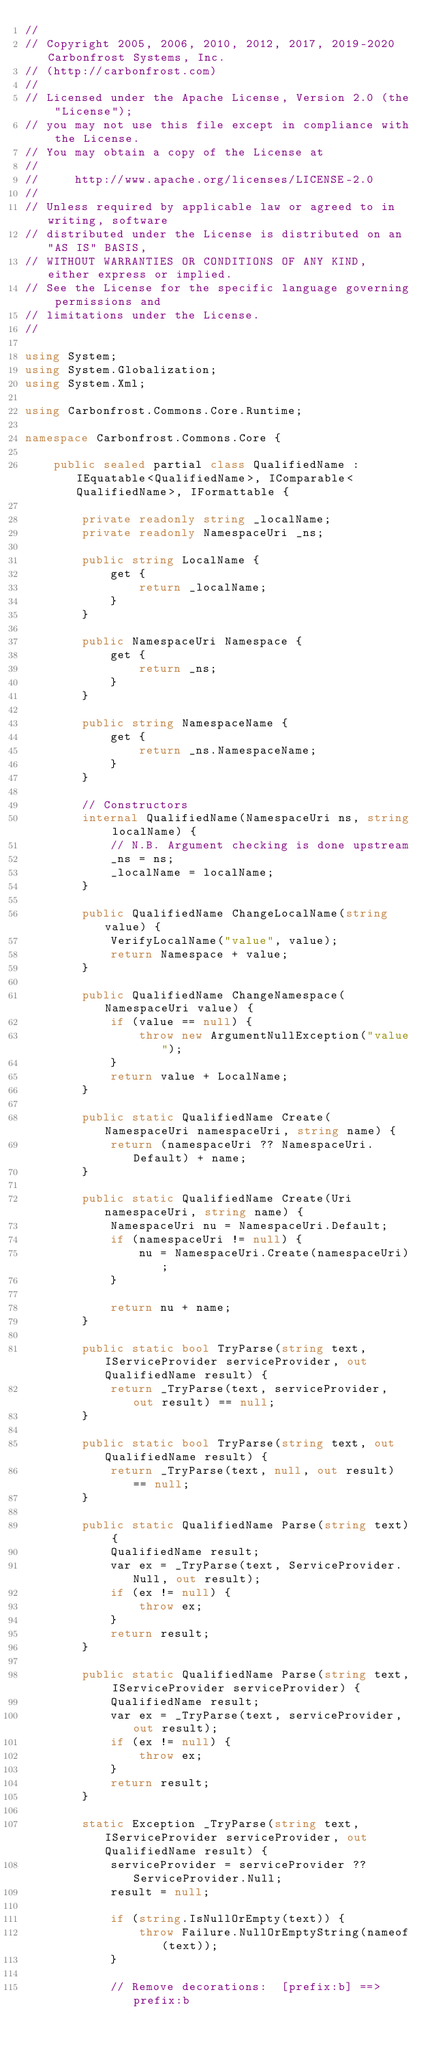Convert code to text. <code><loc_0><loc_0><loc_500><loc_500><_C#_>//
// Copyright 2005, 2006, 2010, 2012, 2017, 2019-2020 Carbonfrost Systems, Inc.
// (http://carbonfrost.com)
//
// Licensed under the Apache License, Version 2.0 (the "License");
// you may not use this file except in compliance with the License.
// You may obtain a copy of the License at
//
//     http://www.apache.org/licenses/LICENSE-2.0
//
// Unless required by applicable law or agreed to in writing, software
// distributed under the License is distributed on an "AS IS" BASIS,
// WITHOUT WARRANTIES OR CONDITIONS OF ANY KIND, either express or implied.
// See the License for the specific language governing permissions and
// limitations under the License.
//

using System;
using System.Globalization;
using System.Xml;

using Carbonfrost.Commons.Core.Runtime;

namespace Carbonfrost.Commons.Core {

    public sealed partial class QualifiedName : IEquatable<QualifiedName>, IComparable<QualifiedName>, IFormattable {

        private readonly string _localName;
        private readonly NamespaceUri _ns;

        public string LocalName {
            get {
                return _localName;
            }
        }

        public NamespaceUri Namespace {
            get {
                return _ns;
            }
        }

        public string NamespaceName {
            get {
                return _ns.NamespaceName;
            }
        }

        // Constructors
        internal QualifiedName(NamespaceUri ns, string localName) {
            // N.B. Argument checking is done upstream
            _ns = ns;
            _localName = localName;
        }

        public QualifiedName ChangeLocalName(string value) {
            VerifyLocalName("value", value);
            return Namespace + value;
        }

        public QualifiedName ChangeNamespace(NamespaceUri value) {
            if (value == null) {
                throw new ArgumentNullException("value");
            }
            return value + LocalName;
        }

        public static QualifiedName Create(NamespaceUri namespaceUri, string name) {
            return (namespaceUri ?? NamespaceUri.Default) + name;
        }

        public static QualifiedName Create(Uri namespaceUri, string name) {
            NamespaceUri nu = NamespaceUri.Default;
            if (namespaceUri != null) {
                nu = NamespaceUri.Create(namespaceUri);
            }

            return nu + name;
        }

        public static bool TryParse(string text, IServiceProvider serviceProvider, out QualifiedName result) {
            return _TryParse(text, serviceProvider, out result) == null;
        }

        public static bool TryParse(string text, out QualifiedName result) {
            return _TryParse(text, null, out result) == null;
        }

        public static QualifiedName Parse(string text) {
            QualifiedName result;
            var ex = _TryParse(text, ServiceProvider.Null, out result);
            if (ex != null) {
                throw ex;
            }
            return result;
        }

        public static QualifiedName Parse(string text, IServiceProvider serviceProvider) {
            QualifiedName result;
            var ex = _TryParse(text, serviceProvider, out result);
            if (ex != null) {
                throw ex;
            }
            return result;
        }

        static Exception _TryParse(string text, IServiceProvider serviceProvider, out QualifiedName result) {
            serviceProvider = serviceProvider ?? ServiceProvider.Null;
            result = null;

            if (string.IsNullOrEmpty(text)) {
                throw Failure.NullOrEmptyString(nameof(text));
            }

            // Remove decorations:  [prefix:b] ==> prefix:b</code> 